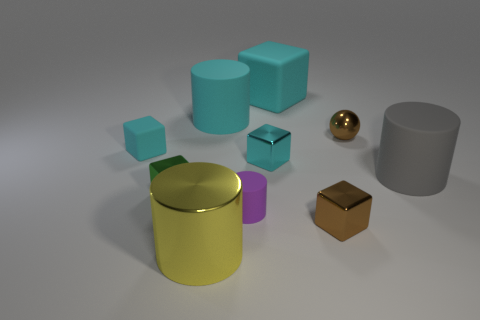How many other things are there of the same color as the small sphere?
Provide a short and direct response. 1. What number of objects are metal blocks or green cubes?
Offer a terse response. 3. How many objects are purple things or large things on the left side of the large gray thing?
Ensure brevity in your answer.  4. Does the green thing have the same material as the gray object?
Provide a short and direct response. No. How many other things are there of the same material as the yellow thing?
Keep it short and to the point. 4. Are there more small purple matte cylinders than large rubber things?
Offer a very short reply. No. There is a object that is left of the tiny green object; does it have the same shape as the yellow object?
Make the answer very short. No. Is the number of green cubes less than the number of yellow metallic balls?
Keep it short and to the point. No. What is the material of the brown block that is the same size as the purple cylinder?
Offer a very short reply. Metal. Is the color of the small cylinder the same as the large metallic cylinder that is right of the green metal cube?
Your answer should be very brief. No. 